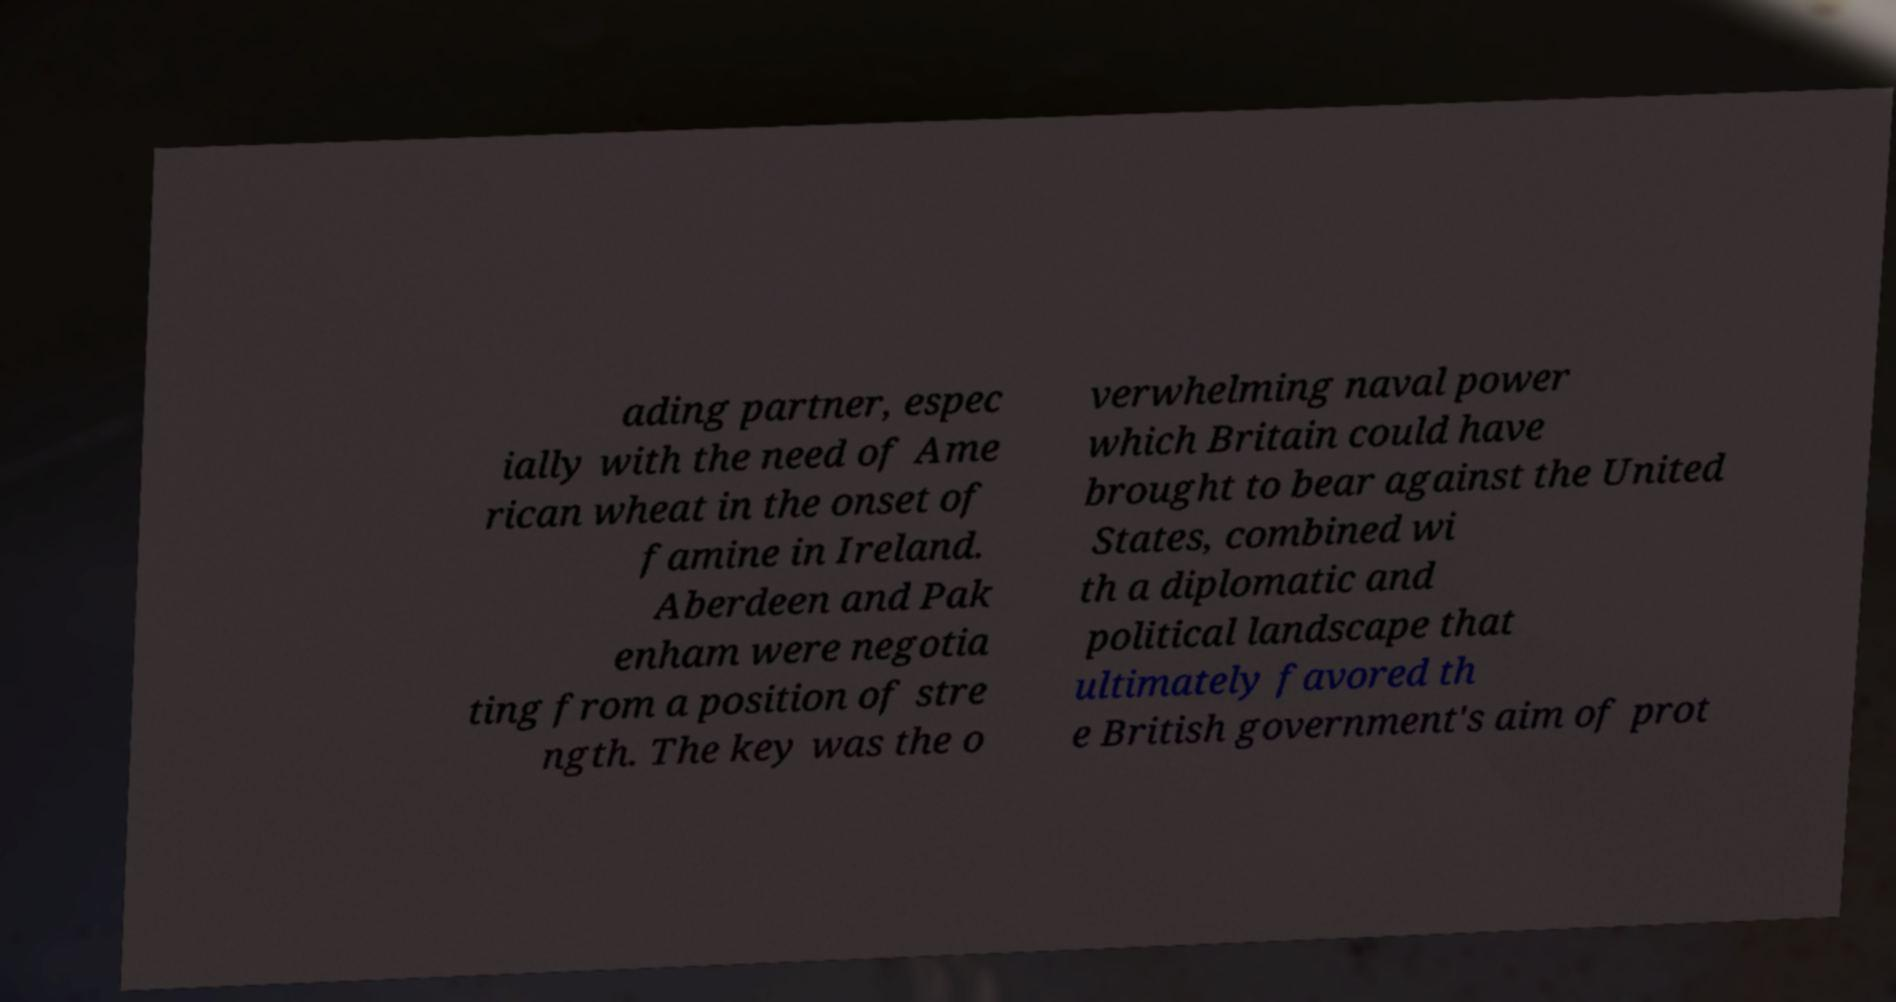For documentation purposes, I need the text within this image transcribed. Could you provide that? ading partner, espec ially with the need of Ame rican wheat in the onset of famine in Ireland. Aberdeen and Pak enham were negotia ting from a position of stre ngth. The key was the o verwhelming naval power which Britain could have brought to bear against the United States, combined wi th a diplomatic and political landscape that ultimately favored th e British government's aim of prot 